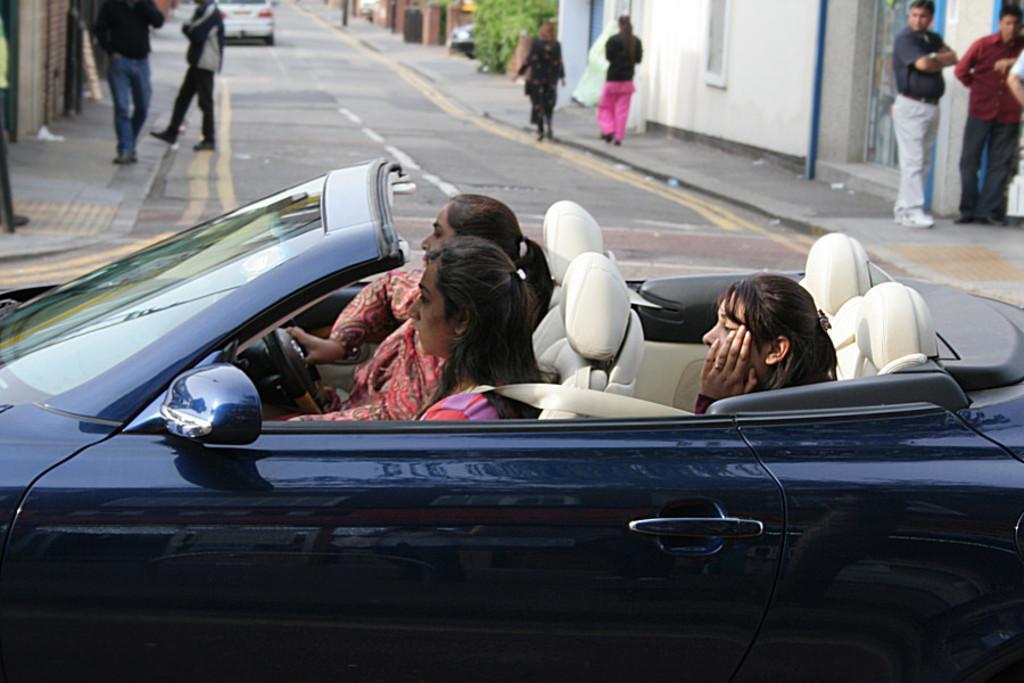In one or two sentences, can you explain what this image depicts? In the image there are three women sat on seat in the car and there are several humans walking on right side and left sides of the road. 